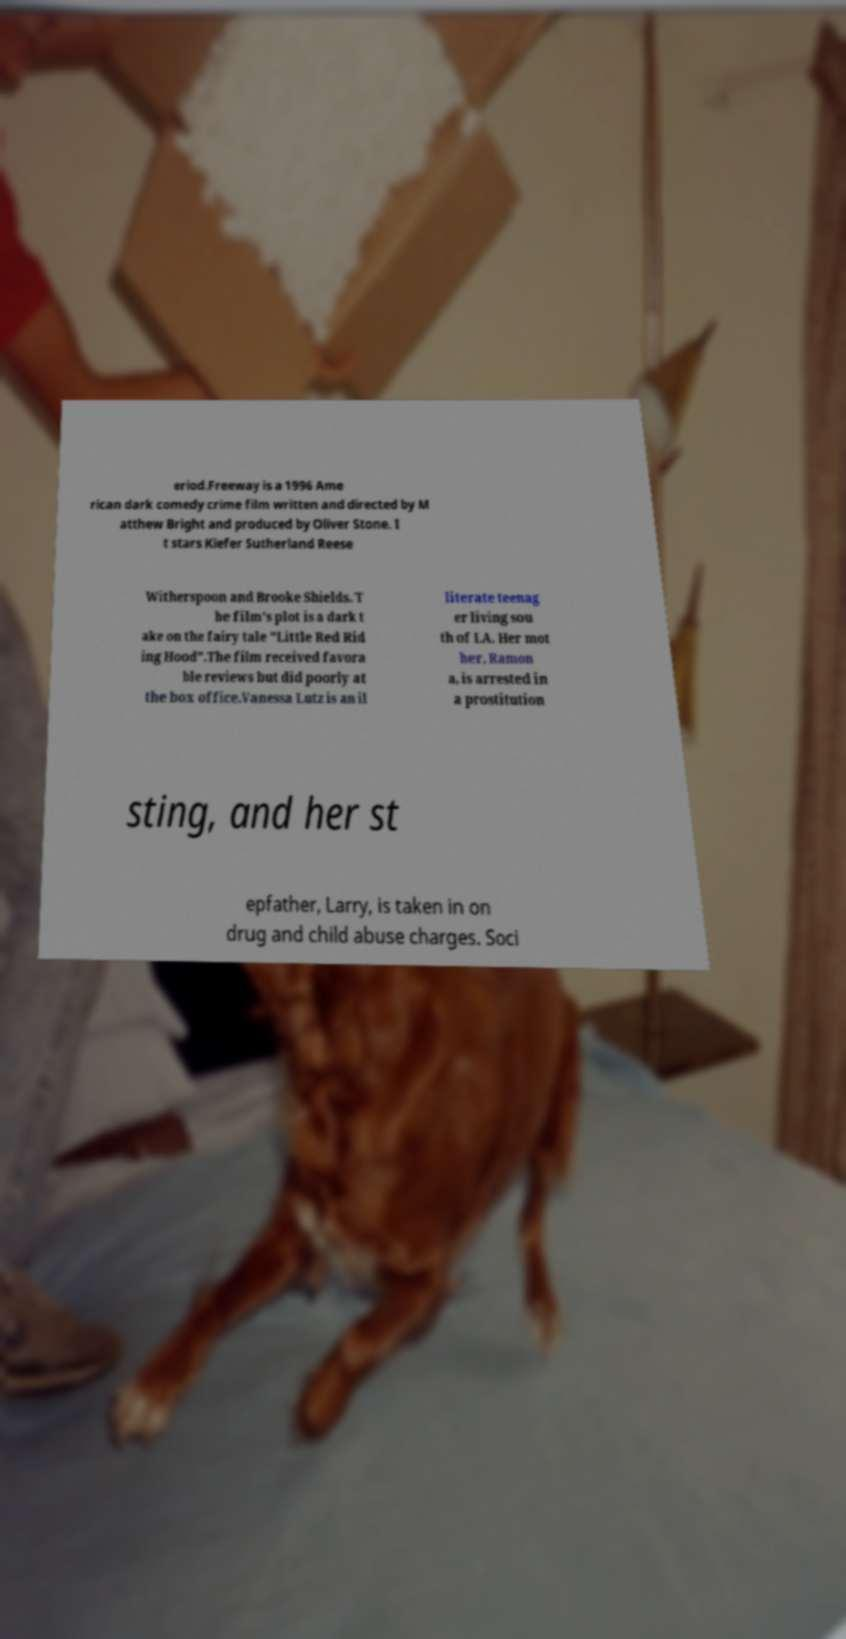Please identify and transcribe the text found in this image. eriod.Freeway is a 1996 Ame rican dark comedy crime film written and directed by M atthew Bright and produced by Oliver Stone. I t stars Kiefer Sutherland Reese Witherspoon and Brooke Shields. T he film's plot is a dark t ake on the fairy tale "Little Red Rid ing Hood".The film received favora ble reviews but did poorly at the box office.Vanessa Lutz is an il literate teenag er living sou th of LA. Her mot her, Ramon a, is arrested in a prostitution sting, and her st epfather, Larry, is taken in on drug and child abuse charges. Soci 